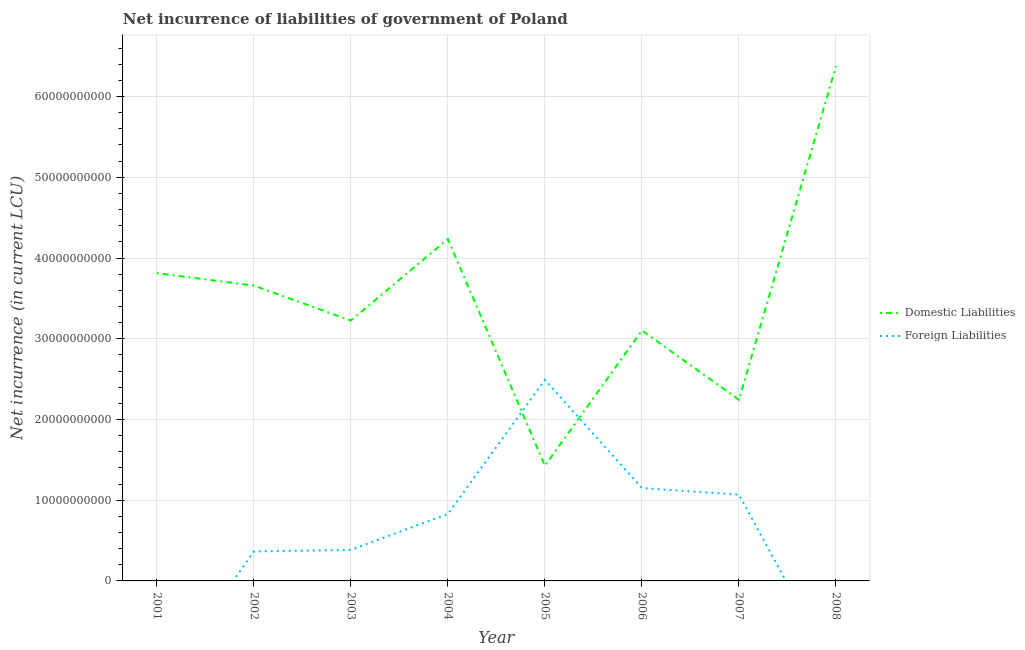How many different coloured lines are there?
Ensure brevity in your answer.  2. Is the number of lines equal to the number of legend labels?
Give a very brief answer. No. What is the net incurrence of domestic liabilities in 2008?
Your answer should be compact. 6.38e+1. Across all years, what is the maximum net incurrence of foreign liabilities?
Keep it short and to the point. 2.49e+1. In which year was the net incurrence of domestic liabilities maximum?
Your answer should be very brief. 2008. What is the total net incurrence of domestic liabilities in the graph?
Keep it short and to the point. 2.81e+11. What is the difference between the net incurrence of foreign liabilities in 2003 and that in 2006?
Give a very brief answer. -7.66e+09. What is the difference between the net incurrence of domestic liabilities in 2004 and the net incurrence of foreign liabilities in 2006?
Keep it short and to the point. 3.08e+1. What is the average net incurrence of foreign liabilities per year?
Provide a succinct answer. 7.86e+09. In the year 2006, what is the difference between the net incurrence of foreign liabilities and net incurrence of domestic liabilities?
Provide a succinct answer. -1.95e+1. In how many years, is the net incurrence of domestic liabilities greater than 36000000000 LCU?
Your answer should be very brief. 4. What is the ratio of the net incurrence of foreign liabilities in 2002 to that in 2004?
Offer a terse response. 0.44. What is the difference between the highest and the second highest net incurrence of domestic liabilities?
Provide a succinct answer. 2.14e+1. What is the difference between the highest and the lowest net incurrence of domestic liabilities?
Keep it short and to the point. 4.95e+1. In how many years, is the net incurrence of domestic liabilities greater than the average net incurrence of domestic liabilities taken over all years?
Keep it short and to the point. 4. Is the sum of the net incurrence of domestic liabilities in 2001 and 2006 greater than the maximum net incurrence of foreign liabilities across all years?
Ensure brevity in your answer.  Yes. Does the net incurrence of foreign liabilities monotonically increase over the years?
Ensure brevity in your answer.  No. Is the net incurrence of foreign liabilities strictly less than the net incurrence of domestic liabilities over the years?
Ensure brevity in your answer.  No. Does the graph contain any zero values?
Provide a succinct answer. Yes. Does the graph contain grids?
Keep it short and to the point. Yes. How many legend labels are there?
Offer a very short reply. 2. How are the legend labels stacked?
Your response must be concise. Vertical. What is the title of the graph?
Give a very brief answer. Net incurrence of liabilities of government of Poland. Does "Frequency of shipment arrival" appear as one of the legend labels in the graph?
Make the answer very short. No. What is the label or title of the X-axis?
Provide a succinct answer. Year. What is the label or title of the Y-axis?
Your response must be concise. Net incurrence (in current LCU). What is the Net incurrence (in current LCU) of Domestic Liabilities in 2001?
Your answer should be very brief. 3.81e+1. What is the Net incurrence (in current LCU) of Domestic Liabilities in 2002?
Keep it short and to the point. 3.66e+1. What is the Net incurrence (in current LCU) in Foreign Liabilities in 2002?
Ensure brevity in your answer.  3.65e+09. What is the Net incurrence (in current LCU) in Domestic Liabilities in 2003?
Offer a terse response. 3.23e+1. What is the Net incurrence (in current LCU) in Foreign Liabilities in 2003?
Provide a short and direct response. 3.85e+09. What is the Net incurrence (in current LCU) of Domestic Liabilities in 2004?
Provide a succinct answer. 4.23e+1. What is the Net incurrence (in current LCU) of Foreign Liabilities in 2004?
Your answer should be very brief. 8.30e+09. What is the Net incurrence (in current LCU) of Domestic Liabilities in 2005?
Provide a short and direct response. 1.43e+1. What is the Net incurrence (in current LCU) in Foreign Liabilities in 2005?
Provide a short and direct response. 2.49e+1. What is the Net incurrence (in current LCU) in Domestic Liabilities in 2006?
Provide a succinct answer. 3.10e+1. What is the Net incurrence (in current LCU) in Foreign Liabilities in 2006?
Your response must be concise. 1.15e+1. What is the Net incurrence (in current LCU) of Domestic Liabilities in 2007?
Provide a short and direct response. 2.24e+1. What is the Net incurrence (in current LCU) of Foreign Liabilities in 2007?
Your response must be concise. 1.07e+1. What is the Net incurrence (in current LCU) in Domestic Liabilities in 2008?
Your answer should be very brief. 6.38e+1. What is the Net incurrence (in current LCU) of Foreign Liabilities in 2008?
Your answer should be compact. 0. Across all years, what is the maximum Net incurrence (in current LCU) in Domestic Liabilities?
Offer a terse response. 6.38e+1. Across all years, what is the maximum Net incurrence (in current LCU) in Foreign Liabilities?
Provide a succinct answer. 2.49e+1. Across all years, what is the minimum Net incurrence (in current LCU) in Domestic Liabilities?
Provide a succinct answer. 1.43e+1. Across all years, what is the minimum Net incurrence (in current LCU) in Foreign Liabilities?
Ensure brevity in your answer.  0. What is the total Net incurrence (in current LCU) in Domestic Liabilities in the graph?
Your answer should be very brief. 2.81e+11. What is the total Net incurrence (in current LCU) of Foreign Liabilities in the graph?
Give a very brief answer. 6.29e+1. What is the difference between the Net incurrence (in current LCU) in Domestic Liabilities in 2001 and that in 2002?
Provide a succinct answer. 1.55e+09. What is the difference between the Net incurrence (in current LCU) of Domestic Liabilities in 2001 and that in 2003?
Keep it short and to the point. 5.87e+09. What is the difference between the Net incurrence (in current LCU) of Domestic Liabilities in 2001 and that in 2004?
Keep it short and to the point. -4.22e+09. What is the difference between the Net incurrence (in current LCU) in Domestic Liabilities in 2001 and that in 2005?
Make the answer very short. 2.39e+1. What is the difference between the Net incurrence (in current LCU) of Domestic Liabilities in 2001 and that in 2006?
Your response must be concise. 7.10e+09. What is the difference between the Net incurrence (in current LCU) in Domestic Liabilities in 2001 and that in 2007?
Make the answer very short. 1.57e+1. What is the difference between the Net incurrence (in current LCU) of Domestic Liabilities in 2001 and that in 2008?
Provide a succinct answer. -2.56e+1. What is the difference between the Net incurrence (in current LCU) in Domestic Liabilities in 2002 and that in 2003?
Offer a very short reply. 4.32e+09. What is the difference between the Net incurrence (in current LCU) of Foreign Liabilities in 2002 and that in 2003?
Provide a short and direct response. -1.99e+08. What is the difference between the Net incurrence (in current LCU) of Domestic Liabilities in 2002 and that in 2004?
Make the answer very short. -5.77e+09. What is the difference between the Net incurrence (in current LCU) in Foreign Liabilities in 2002 and that in 2004?
Your answer should be very brief. -4.65e+09. What is the difference between the Net incurrence (in current LCU) in Domestic Liabilities in 2002 and that in 2005?
Give a very brief answer. 2.23e+1. What is the difference between the Net incurrence (in current LCU) of Foreign Liabilities in 2002 and that in 2005?
Give a very brief answer. -2.13e+1. What is the difference between the Net incurrence (in current LCU) in Domestic Liabilities in 2002 and that in 2006?
Your answer should be very brief. 5.56e+09. What is the difference between the Net incurrence (in current LCU) in Foreign Liabilities in 2002 and that in 2006?
Offer a very short reply. -7.85e+09. What is the difference between the Net incurrence (in current LCU) in Domestic Liabilities in 2002 and that in 2007?
Ensure brevity in your answer.  1.41e+1. What is the difference between the Net incurrence (in current LCU) of Foreign Liabilities in 2002 and that in 2007?
Your answer should be compact. -7.03e+09. What is the difference between the Net incurrence (in current LCU) of Domestic Liabilities in 2002 and that in 2008?
Give a very brief answer. -2.72e+1. What is the difference between the Net incurrence (in current LCU) of Domestic Liabilities in 2003 and that in 2004?
Offer a very short reply. -1.01e+1. What is the difference between the Net incurrence (in current LCU) of Foreign Liabilities in 2003 and that in 2004?
Keep it short and to the point. -4.45e+09. What is the difference between the Net incurrence (in current LCU) of Domestic Liabilities in 2003 and that in 2005?
Provide a short and direct response. 1.80e+1. What is the difference between the Net incurrence (in current LCU) of Foreign Liabilities in 2003 and that in 2005?
Your answer should be very brief. -2.11e+1. What is the difference between the Net incurrence (in current LCU) in Domestic Liabilities in 2003 and that in 2006?
Your answer should be compact. 1.23e+09. What is the difference between the Net incurrence (in current LCU) of Foreign Liabilities in 2003 and that in 2006?
Give a very brief answer. -7.66e+09. What is the difference between the Net incurrence (in current LCU) of Domestic Liabilities in 2003 and that in 2007?
Keep it short and to the point. 9.82e+09. What is the difference between the Net incurrence (in current LCU) of Foreign Liabilities in 2003 and that in 2007?
Provide a succinct answer. -6.84e+09. What is the difference between the Net incurrence (in current LCU) in Domestic Liabilities in 2003 and that in 2008?
Provide a short and direct response. -3.15e+1. What is the difference between the Net incurrence (in current LCU) in Domestic Liabilities in 2004 and that in 2005?
Keep it short and to the point. 2.81e+1. What is the difference between the Net incurrence (in current LCU) in Foreign Liabilities in 2004 and that in 2005?
Offer a terse response. -1.66e+1. What is the difference between the Net incurrence (in current LCU) in Domestic Liabilities in 2004 and that in 2006?
Give a very brief answer. 1.13e+1. What is the difference between the Net incurrence (in current LCU) of Foreign Liabilities in 2004 and that in 2006?
Offer a terse response. -3.20e+09. What is the difference between the Net incurrence (in current LCU) in Domestic Liabilities in 2004 and that in 2007?
Ensure brevity in your answer.  1.99e+1. What is the difference between the Net incurrence (in current LCU) in Foreign Liabilities in 2004 and that in 2007?
Offer a terse response. -2.38e+09. What is the difference between the Net incurrence (in current LCU) of Domestic Liabilities in 2004 and that in 2008?
Make the answer very short. -2.14e+1. What is the difference between the Net incurrence (in current LCU) of Domestic Liabilities in 2005 and that in 2006?
Your response must be concise. -1.68e+1. What is the difference between the Net incurrence (in current LCU) of Foreign Liabilities in 2005 and that in 2006?
Your answer should be compact. 1.34e+1. What is the difference between the Net incurrence (in current LCU) in Domestic Liabilities in 2005 and that in 2007?
Make the answer very short. -8.17e+09. What is the difference between the Net incurrence (in current LCU) in Foreign Liabilities in 2005 and that in 2007?
Offer a very short reply. 1.42e+1. What is the difference between the Net incurrence (in current LCU) in Domestic Liabilities in 2005 and that in 2008?
Offer a very short reply. -4.95e+1. What is the difference between the Net incurrence (in current LCU) of Domestic Liabilities in 2006 and that in 2007?
Make the answer very short. 8.58e+09. What is the difference between the Net incurrence (in current LCU) in Foreign Liabilities in 2006 and that in 2007?
Offer a very short reply. 8.20e+08. What is the difference between the Net incurrence (in current LCU) of Domestic Liabilities in 2006 and that in 2008?
Your answer should be very brief. -3.28e+1. What is the difference between the Net incurrence (in current LCU) of Domestic Liabilities in 2007 and that in 2008?
Provide a succinct answer. -4.13e+1. What is the difference between the Net incurrence (in current LCU) of Domestic Liabilities in 2001 and the Net incurrence (in current LCU) of Foreign Liabilities in 2002?
Keep it short and to the point. 3.45e+1. What is the difference between the Net incurrence (in current LCU) of Domestic Liabilities in 2001 and the Net incurrence (in current LCU) of Foreign Liabilities in 2003?
Ensure brevity in your answer.  3.43e+1. What is the difference between the Net incurrence (in current LCU) in Domestic Liabilities in 2001 and the Net incurrence (in current LCU) in Foreign Liabilities in 2004?
Provide a succinct answer. 2.98e+1. What is the difference between the Net incurrence (in current LCU) in Domestic Liabilities in 2001 and the Net incurrence (in current LCU) in Foreign Liabilities in 2005?
Your answer should be very brief. 1.32e+1. What is the difference between the Net incurrence (in current LCU) of Domestic Liabilities in 2001 and the Net incurrence (in current LCU) of Foreign Liabilities in 2006?
Provide a succinct answer. 2.66e+1. What is the difference between the Net incurrence (in current LCU) in Domestic Liabilities in 2001 and the Net incurrence (in current LCU) in Foreign Liabilities in 2007?
Give a very brief answer. 2.74e+1. What is the difference between the Net incurrence (in current LCU) in Domestic Liabilities in 2002 and the Net incurrence (in current LCU) in Foreign Liabilities in 2003?
Keep it short and to the point. 3.27e+1. What is the difference between the Net incurrence (in current LCU) in Domestic Liabilities in 2002 and the Net incurrence (in current LCU) in Foreign Liabilities in 2004?
Give a very brief answer. 2.83e+1. What is the difference between the Net incurrence (in current LCU) in Domestic Liabilities in 2002 and the Net incurrence (in current LCU) in Foreign Liabilities in 2005?
Offer a terse response. 1.17e+1. What is the difference between the Net incurrence (in current LCU) of Domestic Liabilities in 2002 and the Net incurrence (in current LCU) of Foreign Liabilities in 2006?
Give a very brief answer. 2.51e+1. What is the difference between the Net incurrence (in current LCU) in Domestic Liabilities in 2002 and the Net incurrence (in current LCU) in Foreign Liabilities in 2007?
Your answer should be very brief. 2.59e+1. What is the difference between the Net incurrence (in current LCU) of Domestic Liabilities in 2003 and the Net incurrence (in current LCU) of Foreign Liabilities in 2004?
Make the answer very short. 2.40e+1. What is the difference between the Net incurrence (in current LCU) of Domestic Liabilities in 2003 and the Net incurrence (in current LCU) of Foreign Liabilities in 2005?
Your answer should be compact. 7.36e+09. What is the difference between the Net incurrence (in current LCU) of Domestic Liabilities in 2003 and the Net incurrence (in current LCU) of Foreign Liabilities in 2006?
Give a very brief answer. 2.08e+1. What is the difference between the Net incurrence (in current LCU) of Domestic Liabilities in 2003 and the Net incurrence (in current LCU) of Foreign Liabilities in 2007?
Make the answer very short. 2.16e+1. What is the difference between the Net incurrence (in current LCU) in Domestic Liabilities in 2004 and the Net incurrence (in current LCU) in Foreign Liabilities in 2005?
Ensure brevity in your answer.  1.74e+1. What is the difference between the Net incurrence (in current LCU) in Domestic Liabilities in 2004 and the Net incurrence (in current LCU) in Foreign Liabilities in 2006?
Ensure brevity in your answer.  3.08e+1. What is the difference between the Net incurrence (in current LCU) in Domestic Liabilities in 2004 and the Net incurrence (in current LCU) in Foreign Liabilities in 2007?
Your answer should be very brief. 3.17e+1. What is the difference between the Net incurrence (in current LCU) in Domestic Liabilities in 2005 and the Net incurrence (in current LCU) in Foreign Liabilities in 2006?
Provide a short and direct response. 2.76e+09. What is the difference between the Net incurrence (in current LCU) of Domestic Liabilities in 2005 and the Net incurrence (in current LCU) of Foreign Liabilities in 2007?
Make the answer very short. 3.58e+09. What is the difference between the Net incurrence (in current LCU) of Domestic Liabilities in 2006 and the Net incurrence (in current LCU) of Foreign Liabilities in 2007?
Your response must be concise. 2.03e+1. What is the average Net incurrence (in current LCU) of Domestic Liabilities per year?
Provide a succinct answer. 3.51e+1. What is the average Net incurrence (in current LCU) of Foreign Liabilities per year?
Give a very brief answer. 7.86e+09. In the year 2002, what is the difference between the Net incurrence (in current LCU) in Domestic Liabilities and Net incurrence (in current LCU) in Foreign Liabilities?
Provide a succinct answer. 3.29e+1. In the year 2003, what is the difference between the Net incurrence (in current LCU) in Domestic Liabilities and Net incurrence (in current LCU) in Foreign Liabilities?
Keep it short and to the point. 2.84e+1. In the year 2004, what is the difference between the Net incurrence (in current LCU) in Domestic Liabilities and Net incurrence (in current LCU) in Foreign Liabilities?
Provide a succinct answer. 3.40e+1. In the year 2005, what is the difference between the Net incurrence (in current LCU) in Domestic Liabilities and Net incurrence (in current LCU) in Foreign Liabilities?
Your answer should be very brief. -1.06e+1. In the year 2006, what is the difference between the Net incurrence (in current LCU) in Domestic Liabilities and Net incurrence (in current LCU) in Foreign Liabilities?
Ensure brevity in your answer.  1.95e+1. In the year 2007, what is the difference between the Net incurrence (in current LCU) of Domestic Liabilities and Net incurrence (in current LCU) of Foreign Liabilities?
Your answer should be compact. 1.18e+1. What is the ratio of the Net incurrence (in current LCU) of Domestic Liabilities in 2001 to that in 2002?
Offer a terse response. 1.04. What is the ratio of the Net incurrence (in current LCU) of Domestic Liabilities in 2001 to that in 2003?
Give a very brief answer. 1.18. What is the ratio of the Net incurrence (in current LCU) of Domestic Liabilities in 2001 to that in 2004?
Keep it short and to the point. 0.9. What is the ratio of the Net incurrence (in current LCU) in Domestic Liabilities in 2001 to that in 2005?
Offer a very short reply. 2.67. What is the ratio of the Net incurrence (in current LCU) of Domestic Liabilities in 2001 to that in 2006?
Keep it short and to the point. 1.23. What is the ratio of the Net incurrence (in current LCU) of Domestic Liabilities in 2001 to that in 2007?
Your answer should be very brief. 1.7. What is the ratio of the Net incurrence (in current LCU) of Domestic Liabilities in 2001 to that in 2008?
Provide a succinct answer. 0.6. What is the ratio of the Net incurrence (in current LCU) in Domestic Liabilities in 2002 to that in 2003?
Keep it short and to the point. 1.13. What is the ratio of the Net incurrence (in current LCU) in Foreign Liabilities in 2002 to that in 2003?
Keep it short and to the point. 0.95. What is the ratio of the Net incurrence (in current LCU) of Domestic Liabilities in 2002 to that in 2004?
Your answer should be compact. 0.86. What is the ratio of the Net incurrence (in current LCU) in Foreign Liabilities in 2002 to that in 2004?
Provide a succinct answer. 0.44. What is the ratio of the Net incurrence (in current LCU) in Domestic Liabilities in 2002 to that in 2005?
Keep it short and to the point. 2.56. What is the ratio of the Net incurrence (in current LCU) in Foreign Liabilities in 2002 to that in 2005?
Keep it short and to the point. 0.15. What is the ratio of the Net incurrence (in current LCU) of Domestic Liabilities in 2002 to that in 2006?
Offer a terse response. 1.18. What is the ratio of the Net incurrence (in current LCU) in Foreign Liabilities in 2002 to that in 2006?
Your response must be concise. 0.32. What is the ratio of the Net incurrence (in current LCU) in Domestic Liabilities in 2002 to that in 2007?
Offer a very short reply. 1.63. What is the ratio of the Net incurrence (in current LCU) in Foreign Liabilities in 2002 to that in 2007?
Give a very brief answer. 0.34. What is the ratio of the Net incurrence (in current LCU) of Domestic Liabilities in 2002 to that in 2008?
Keep it short and to the point. 0.57. What is the ratio of the Net incurrence (in current LCU) of Domestic Liabilities in 2003 to that in 2004?
Your answer should be compact. 0.76. What is the ratio of the Net incurrence (in current LCU) in Foreign Liabilities in 2003 to that in 2004?
Give a very brief answer. 0.46. What is the ratio of the Net incurrence (in current LCU) of Domestic Liabilities in 2003 to that in 2005?
Ensure brevity in your answer.  2.26. What is the ratio of the Net incurrence (in current LCU) in Foreign Liabilities in 2003 to that in 2005?
Provide a succinct answer. 0.15. What is the ratio of the Net incurrence (in current LCU) of Domestic Liabilities in 2003 to that in 2006?
Give a very brief answer. 1.04. What is the ratio of the Net incurrence (in current LCU) of Foreign Liabilities in 2003 to that in 2006?
Your answer should be compact. 0.33. What is the ratio of the Net incurrence (in current LCU) in Domestic Liabilities in 2003 to that in 2007?
Provide a short and direct response. 1.44. What is the ratio of the Net incurrence (in current LCU) in Foreign Liabilities in 2003 to that in 2007?
Give a very brief answer. 0.36. What is the ratio of the Net incurrence (in current LCU) of Domestic Liabilities in 2003 to that in 2008?
Ensure brevity in your answer.  0.51. What is the ratio of the Net incurrence (in current LCU) of Domestic Liabilities in 2004 to that in 2005?
Offer a terse response. 2.97. What is the ratio of the Net incurrence (in current LCU) in Domestic Liabilities in 2004 to that in 2006?
Ensure brevity in your answer.  1.37. What is the ratio of the Net incurrence (in current LCU) of Foreign Liabilities in 2004 to that in 2006?
Your response must be concise. 0.72. What is the ratio of the Net incurrence (in current LCU) in Domestic Liabilities in 2004 to that in 2007?
Your answer should be compact. 1.89. What is the ratio of the Net incurrence (in current LCU) of Foreign Liabilities in 2004 to that in 2007?
Offer a very short reply. 0.78. What is the ratio of the Net incurrence (in current LCU) of Domestic Liabilities in 2004 to that in 2008?
Offer a very short reply. 0.66. What is the ratio of the Net incurrence (in current LCU) of Domestic Liabilities in 2005 to that in 2006?
Your answer should be compact. 0.46. What is the ratio of the Net incurrence (in current LCU) of Foreign Liabilities in 2005 to that in 2006?
Your answer should be very brief. 2.16. What is the ratio of the Net incurrence (in current LCU) of Domestic Liabilities in 2005 to that in 2007?
Your answer should be very brief. 0.64. What is the ratio of the Net incurrence (in current LCU) in Foreign Liabilities in 2005 to that in 2007?
Your answer should be compact. 2.33. What is the ratio of the Net incurrence (in current LCU) in Domestic Liabilities in 2005 to that in 2008?
Your answer should be compact. 0.22. What is the ratio of the Net incurrence (in current LCU) in Domestic Liabilities in 2006 to that in 2007?
Offer a terse response. 1.38. What is the ratio of the Net incurrence (in current LCU) of Foreign Liabilities in 2006 to that in 2007?
Give a very brief answer. 1.08. What is the ratio of the Net incurrence (in current LCU) of Domestic Liabilities in 2006 to that in 2008?
Your answer should be very brief. 0.49. What is the ratio of the Net incurrence (in current LCU) in Domestic Liabilities in 2007 to that in 2008?
Your answer should be very brief. 0.35. What is the difference between the highest and the second highest Net incurrence (in current LCU) in Domestic Liabilities?
Ensure brevity in your answer.  2.14e+1. What is the difference between the highest and the second highest Net incurrence (in current LCU) of Foreign Liabilities?
Offer a very short reply. 1.34e+1. What is the difference between the highest and the lowest Net incurrence (in current LCU) in Domestic Liabilities?
Give a very brief answer. 4.95e+1. What is the difference between the highest and the lowest Net incurrence (in current LCU) in Foreign Liabilities?
Your answer should be compact. 2.49e+1. 